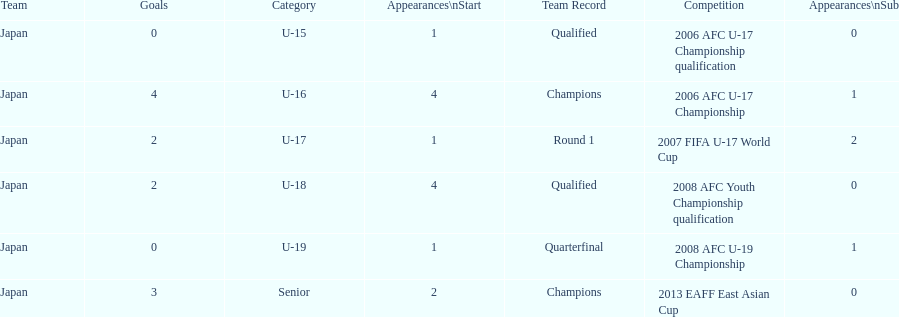In which two competitions did japan lack goals? 2006 AFC U-17 Championship qualification, 2008 AFC U-19 Championship. 